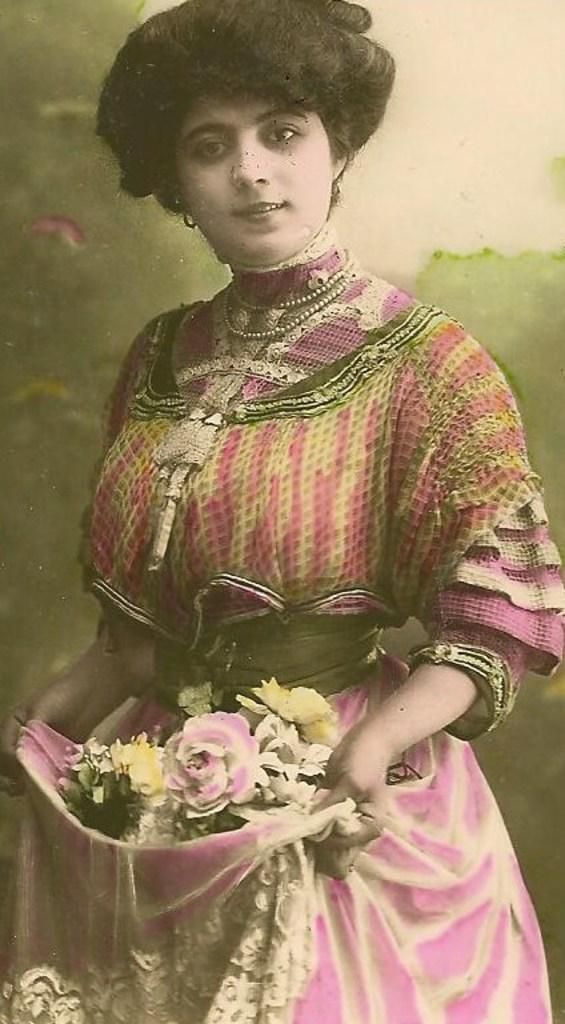What type of artwork is depicted in the image? The image is a painting. Can you describe the main subject of the painting? There is a woman in the painting. What is the woman doing in the painting? The woman is standing and smiling. What is the woman holding in the painting? The woman is holding a cloth with flowers in it. How would you describe the background of the painting? The background of the painting appears blurry. Can you tell me how many people are waiting at the airport in the painting? There is no airport or people waiting in the painting; it features a woman holding a cloth with flowers. What type of food is being prepared in the painting? There is no food or preparation of food depicted in the painting; it focuses on a woman holding a cloth with flowers. 